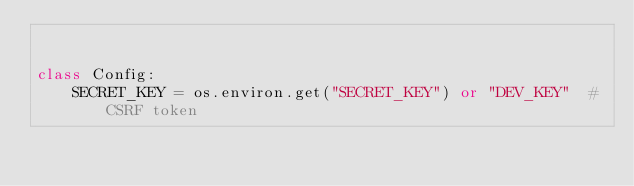<code> <loc_0><loc_0><loc_500><loc_500><_Python_>

class Config:
    SECRET_KEY = os.environ.get("SECRET_KEY") or "DEV_KEY"  # CSRF token
</code> 